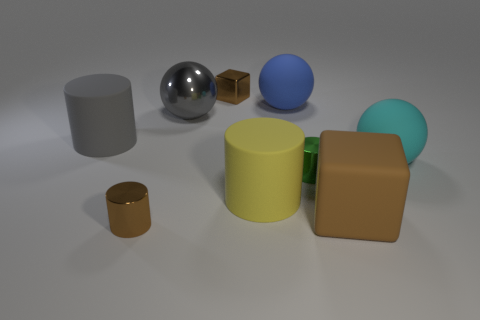Is the big matte cube the same color as the tiny cube?
Ensure brevity in your answer.  Yes. What material is the cylinder that is the same color as the large shiny sphere?
Offer a terse response. Rubber. Do the blue rubber sphere and the yellow cylinder have the same size?
Give a very brief answer. Yes. What material is the big cyan thing?
Your answer should be compact. Rubber. There is a blue object that is the same size as the cyan sphere; what is its material?
Your answer should be compact. Rubber. Is there a gray cube of the same size as the blue rubber sphere?
Your response must be concise. No. Are there an equal number of tiny shiny cylinders that are on the right side of the small green metal cylinder and rubber objects that are to the right of the large yellow rubber object?
Make the answer very short. No. Are there more yellow rubber things than large balls?
Offer a terse response. No. What number of rubber objects are either large gray cylinders or yellow cylinders?
Your response must be concise. 2. How many objects have the same color as the large block?
Give a very brief answer. 2. 